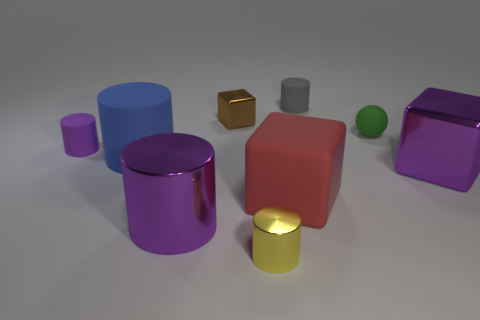Are there any metal things of the same color as the big shiny cylinder?
Give a very brief answer. Yes. The other rubber thing that is the same size as the red matte thing is what color?
Give a very brief answer. Blue. There is a small green thing behind the big metallic cube; what number of tiny brown metallic objects are in front of it?
Offer a very short reply. 0. What number of objects are either cylinders behind the green matte thing or big brown metallic cylinders?
Your answer should be very brief. 1. How many large blocks are the same material as the tiny yellow cylinder?
Your answer should be compact. 1. There is a small object that is the same color as the large shiny cube; what shape is it?
Offer a very short reply. Cylinder. Are there an equal number of big red things in front of the large purple metal cylinder and tiny purple rubber things?
Offer a very short reply. No. There is a metal thing left of the small brown metal cube; what is its size?
Offer a very short reply. Large. What number of small objects are either purple metallic cylinders or metal objects?
Offer a terse response. 2. What color is the other big metallic object that is the same shape as the brown thing?
Offer a terse response. Purple. 